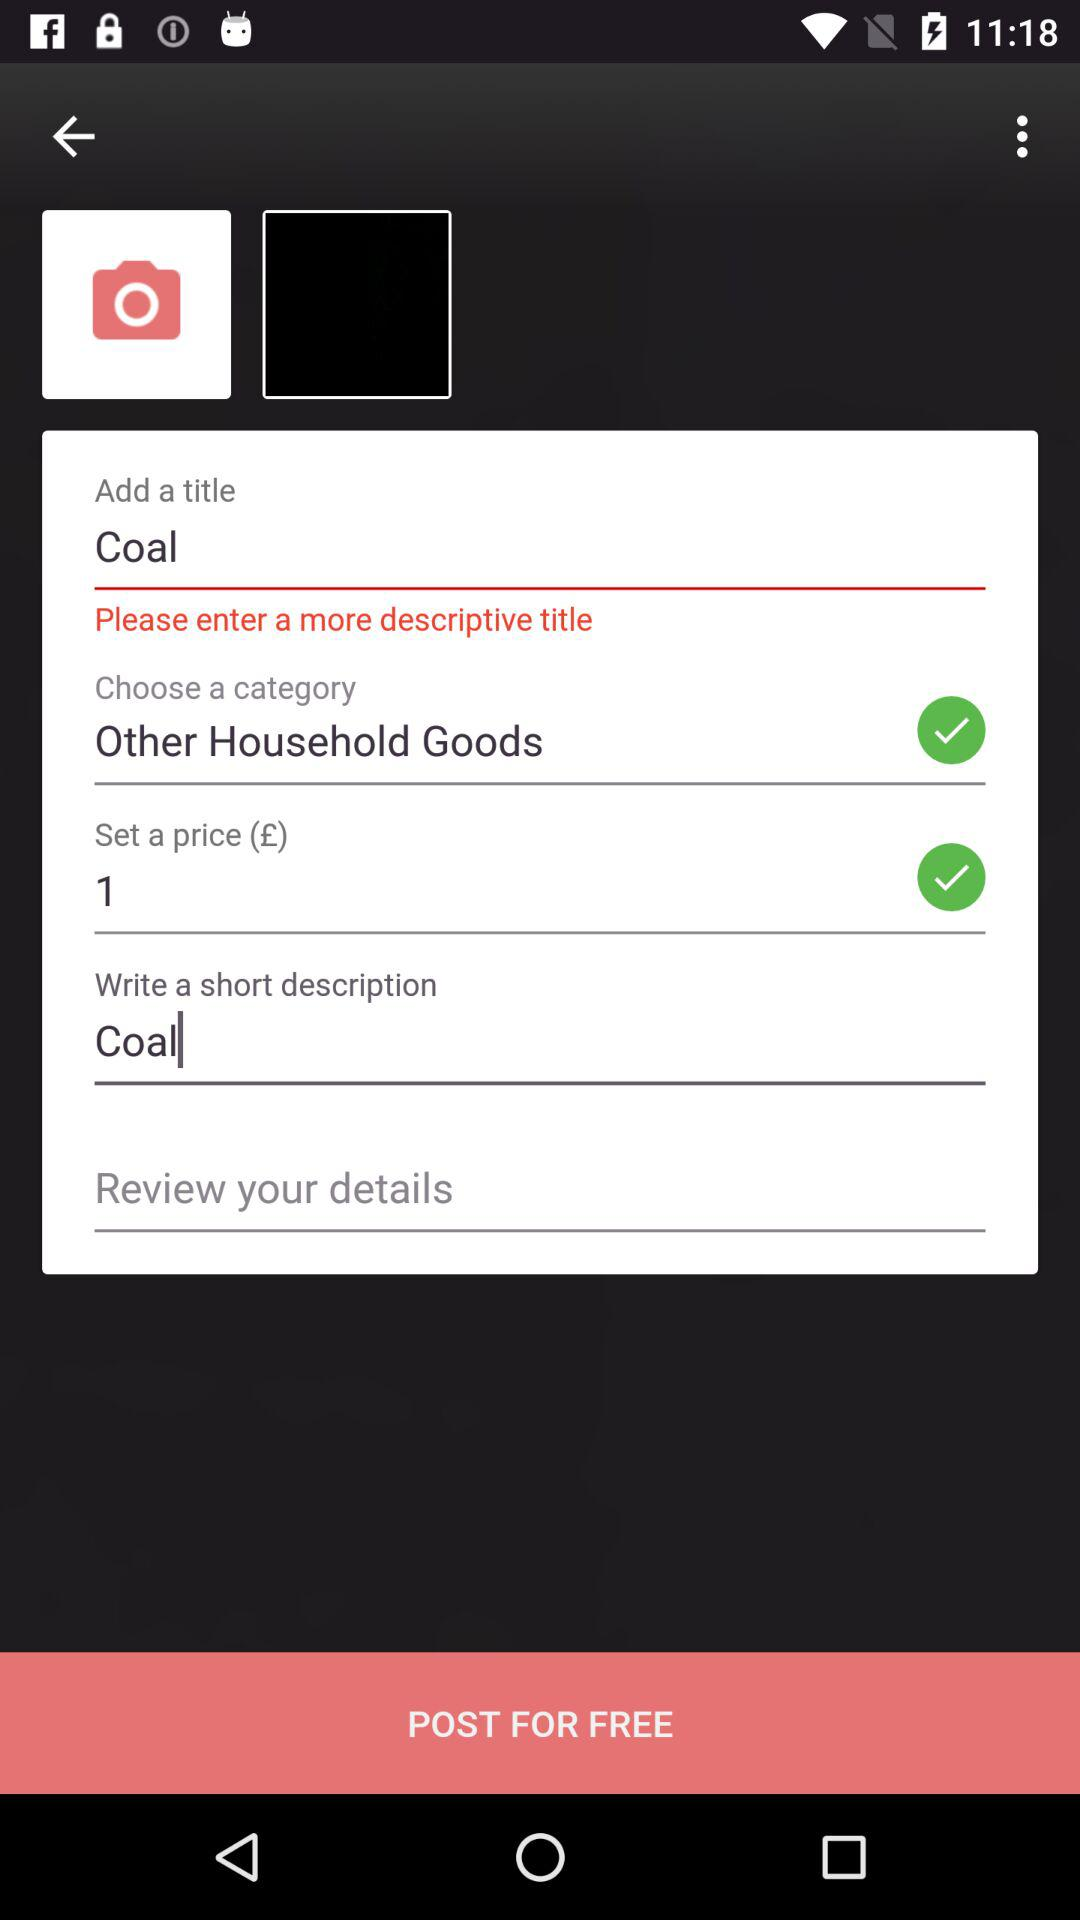What type of category has been chosen? The type of category that has been chosen is "Other Household Goods". 